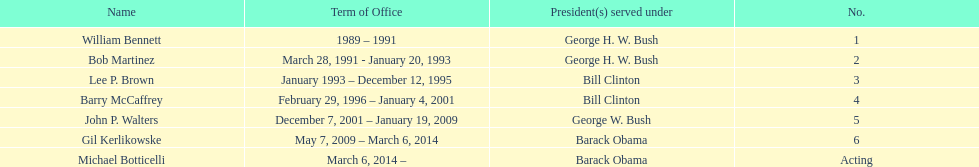How many directors served more than 3 years? 3. 